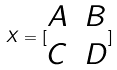<formula> <loc_0><loc_0><loc_500><loc_500>X = [ \begin{matrix} A & B \\ C & D \end{matrix} ]</formula> 